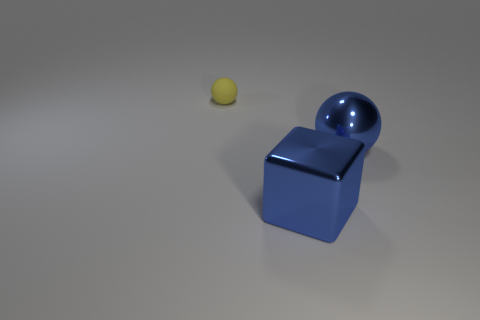Add 3 blue metal objects. How many objects exist? 6 Subtract all balls. How many objects are left? 1 Add 2 big cubes. How many big cubes are left? 3 Add 1 big shiny spheres. How many big shiny spheres exist? 2 Subtract 0 red cubes. How many objects are left? 3 Subtract all shiny cylinders. Subtract all yellow matte things. How many objects are left? 2 